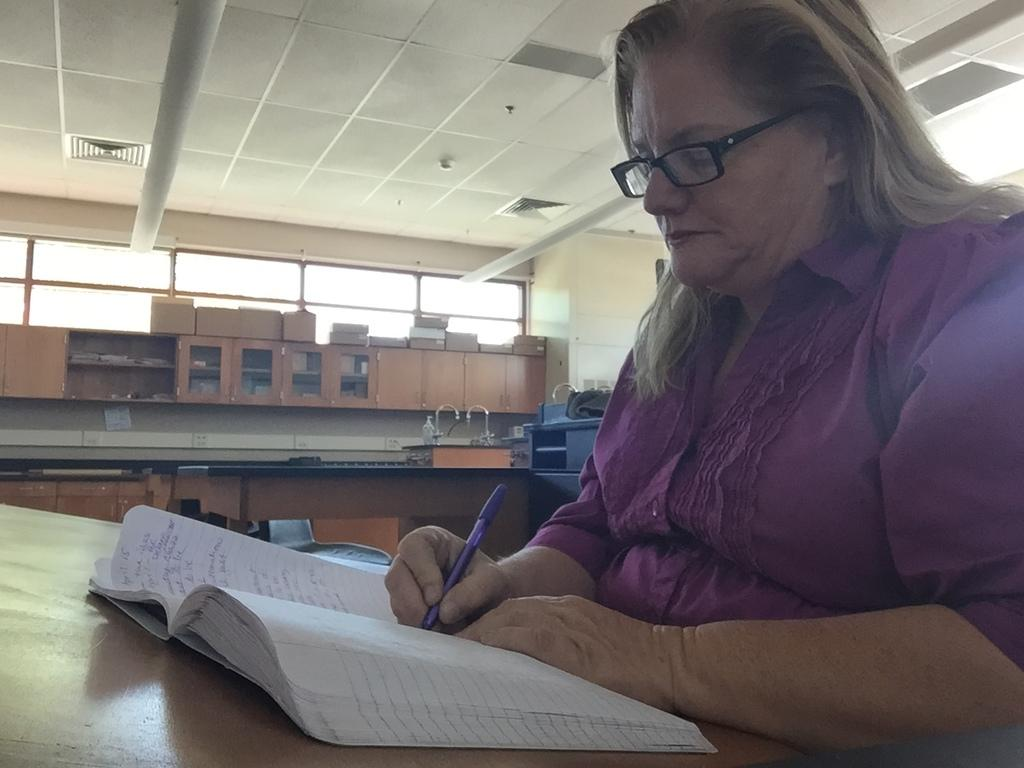Who is the person in the image? There is a woman in the image. What is the woman doing in the image? The woman is writing on a book. What can be seen behind the woman in the image? There are cupboards behind the woman. What type of fixtures are visible in the image? There are taps visible in the image. What is visible in the background of the image? There are windows in the background of the image. What type of truck can be seen delivering news in the image? There is no truck or news delivery depicted in the image; it features a woman writing on a book with cupboards, taps, and windows visible in the background. 